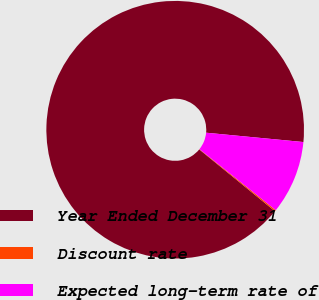Convert chart to OTSL. <chart><loc_0><loc_0><loc_500><loc_500><pie_chart><fcel>Year Ended December 31<fcel>Discount rate<fcel>Expected long-term rate of<nl><fcel>90.62%<fcel>0.17%<fcel>9.21%<nl></chart> 